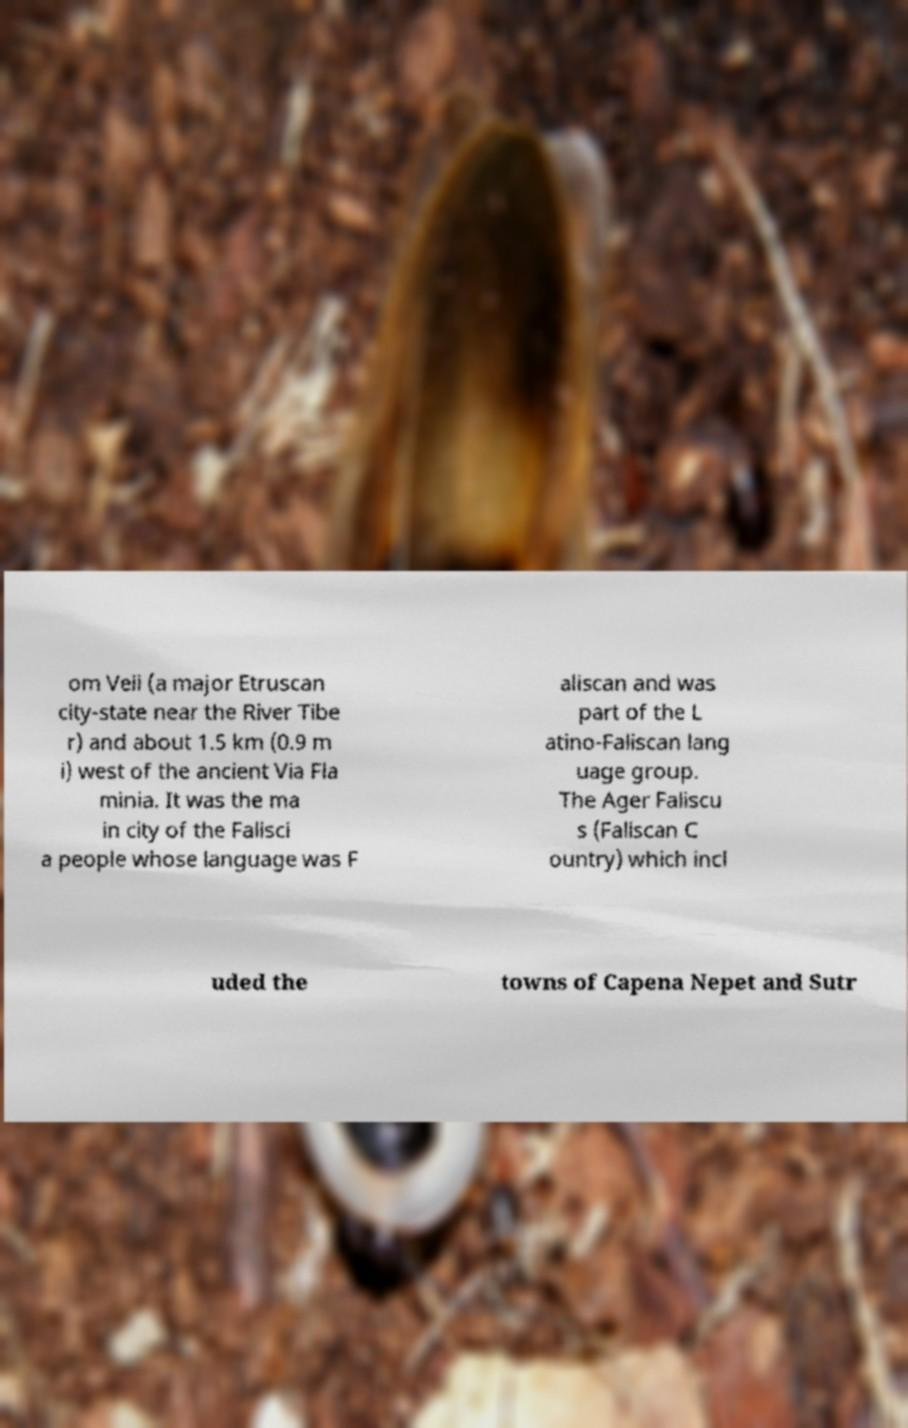There's text embedded in this image that I need extracted. Can you transcribe it verbatim? om Veii (a major Etruscan city-state near the River Tibe r) and about 1.5 km (0.9 m i) west of the ancient Via Fla minia. It was the ma in city of the Falisci a people whose language was F aliscan and was part of the L atino-Faliscan lang uage group. The Ager Faliscu s (Faliscan C ountry) which incl uded the towns of Capena Nepet and Sutr 